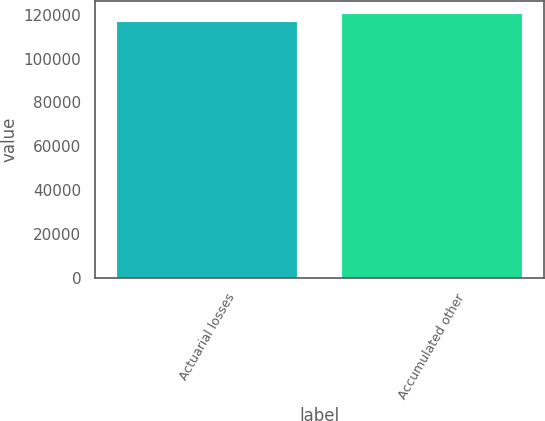Convert chart to OTSL. <chart><loc_0><loc_0><loc_500><loc_500><bar_chart><fcel>Actuarial losses<fcel>Accumulated other<nl><fcel>116400<fcel>120230<nl></chart> 